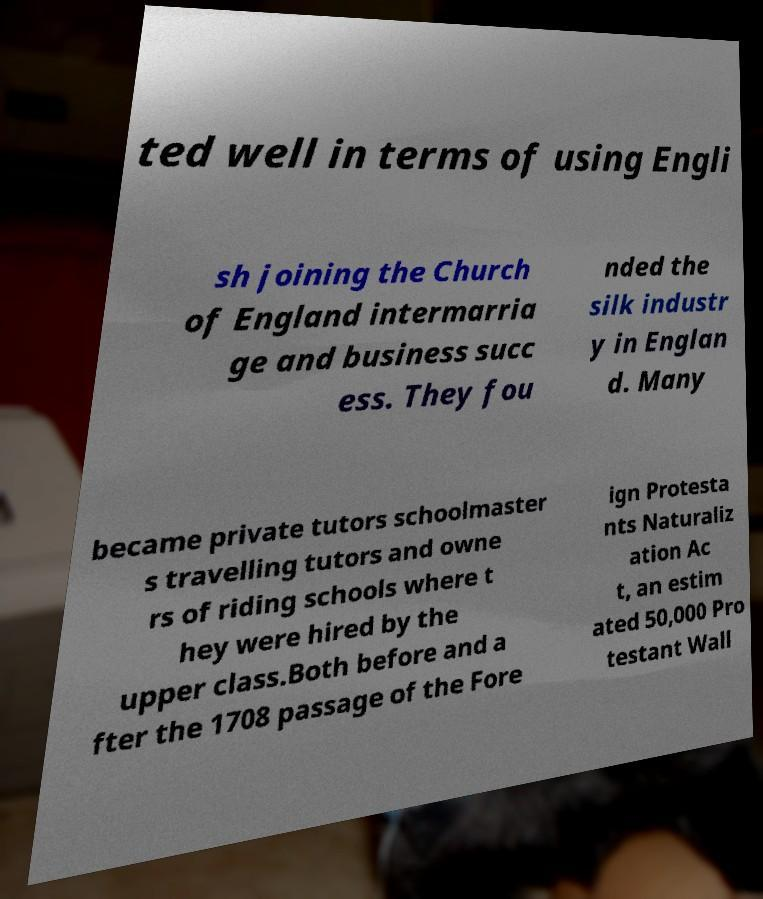Could you assist in decoding the text presented in this image and type it out clearly? ted well in terms of using Engli sh joining the Church of England intermarria ge and business succ ess. They fou nded the silk industr y in Englan d. Many became private tutors schoolmaster s travelling tutors and owne rs of riding schools where t hey were hired by the upper class.Both before and a fter the 1708 passage of the Fore ign Protesta nts Naturaliz ation Ac t, an estim ated 50,000 Pro testant Wall 